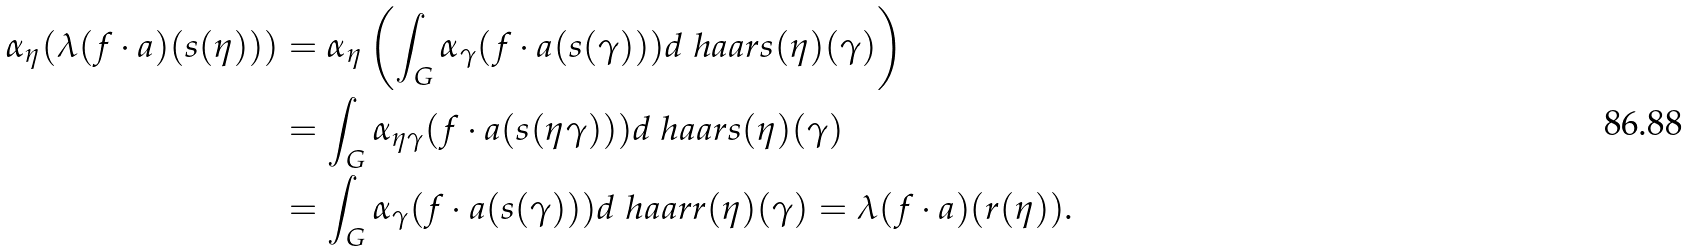Convert formula to latex. <formula><loc_0><loc_0><loc_500><loc_500>\alpha _ { \eta } ( \lambda ( f \cdot a ) ( s ( \eta ) ) ) & = \alpha _ { \eta } \left ( \int _ { G } \alpha _ { \gamma } ( f \cdot a ( s ( \gamma ) ) ) d \ h a a r { s ( \eta ) } ( \gamma ) \right ) \\ & = \int _ { G } \alpha _ { \eta \gamma } ( f \cdot a ( s ( \eta \gamma ) ) ) d \ h a a r { s ( \eta ) } ( \gamma ) \\ & = \int _ { G } \alpha _ { \gamma } ( f \cdot a ( s ( \gamma ) ) ) d \ h a a r { r ( \eta ) } ( \gamma ) = \lambda ( f \cdot a ) ( r ( \eta ) ) .</formula> 